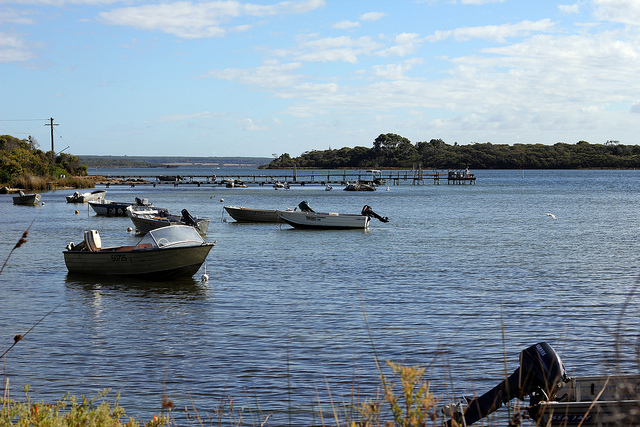Can you describe a realistic day for a local fisherman's family on this lake? For a local fisherman's family, a typical day on this lake begins at the crack of dawn. The fisherman wakes early, prepping his gear with care and loading the boat while the first light of day begins to warm the sky. His children, rubbing sleep out of their eyes, join him to help with the preparations, eager to spend a day on the water. As the boat casts off from the dock, the family feels the cool, fresh morning air and the gentle sway of the water. The fisherman finds his favorite spot and casts his lines, teaching his children the delicate art of fishing. The morning passes peacefully, filled with laughter, shared stories, and the satisfaction of each catch. By midday, the family enjoys a picnic on a small island or along the shore, with the children playing and exploring the surroundings. As the day progresses, they continue fishing, soaking up the leisurely pace of their life on the lake, until the sun begins to set. Returning home, they bring their catch to the local market or enjoy a well-earned family dinner, grateful for the beauty and bounty the lake provides. 